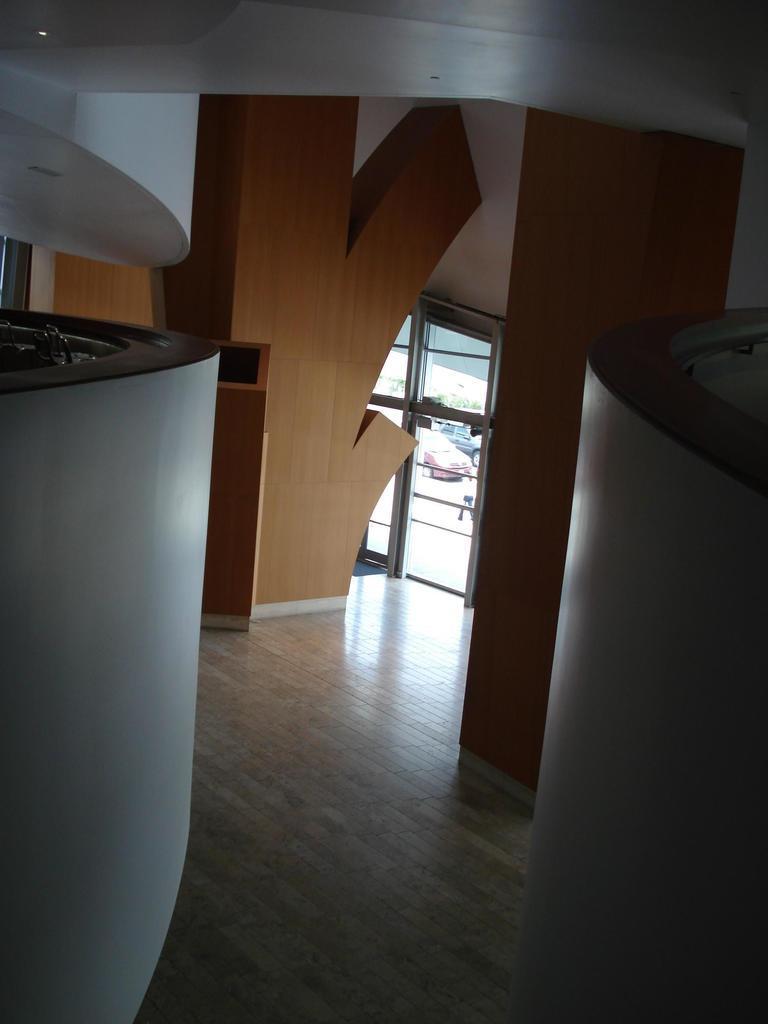Could you give a brief overview of what you see in this image? In this image I can see the ground, the white colored wall, the ceiling, a light to the ceiling, the brown colored walls and the glass doors through which I can see few vehicles on the ground. 